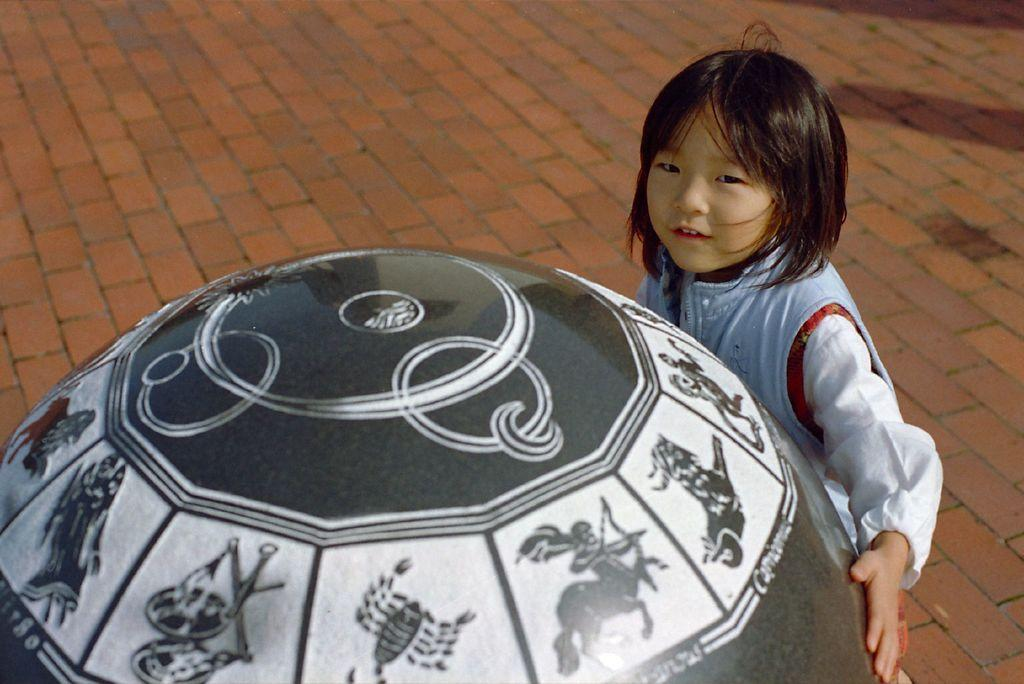What is the main subject of the image? The main subject of the image is a child. What is the child standing near? The child is standing near a ball-shaped object. What is depicted on the ball-shaped object? The ball-shaped object has images of different zodiac signs. What type of flooring is visible in the image? There is a brick floor in the image. How many balloons are tied to the child's wrist in the image? There are no balloons present in the image; the child is standing near a ball-shaped object with zodiac signs. 